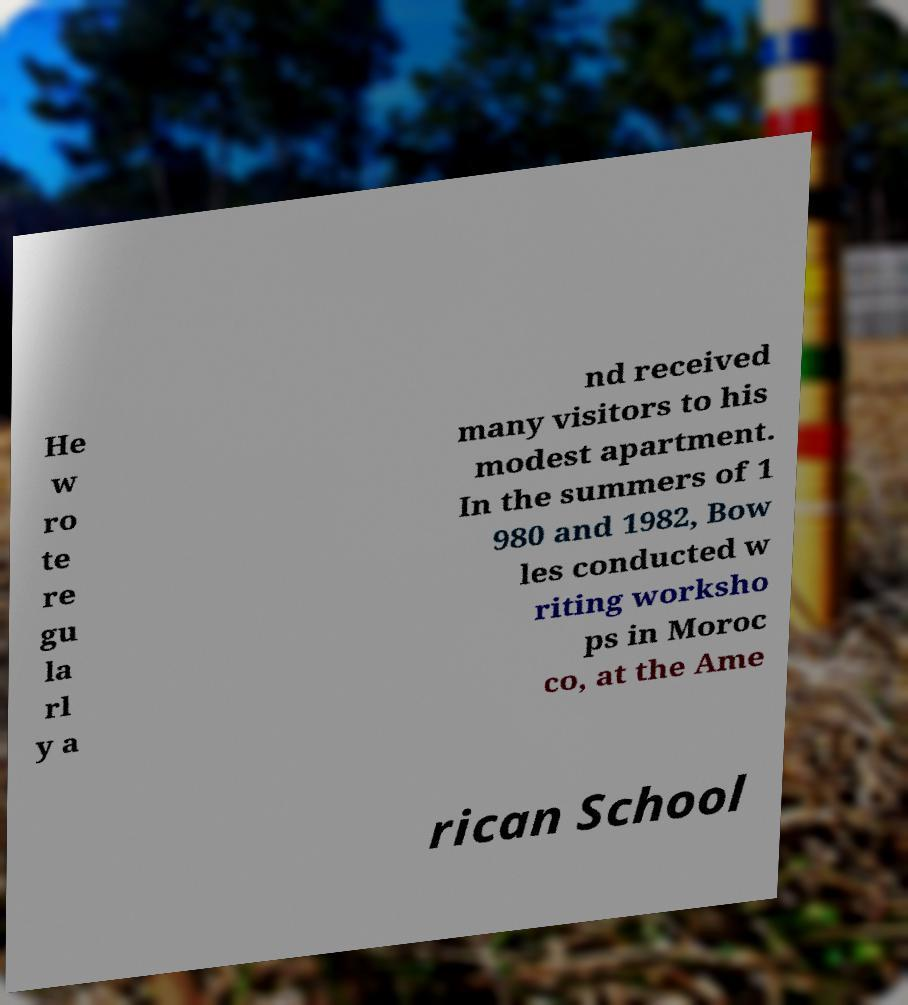Could you extract and type out the text from this image? He w ro te re gu la rl y a nd received many visitors to his modest apartment. In the summers of 1 980 and 1982, Bow les conducted w riting worksho ps in Moroc co, at the Ame rican School 